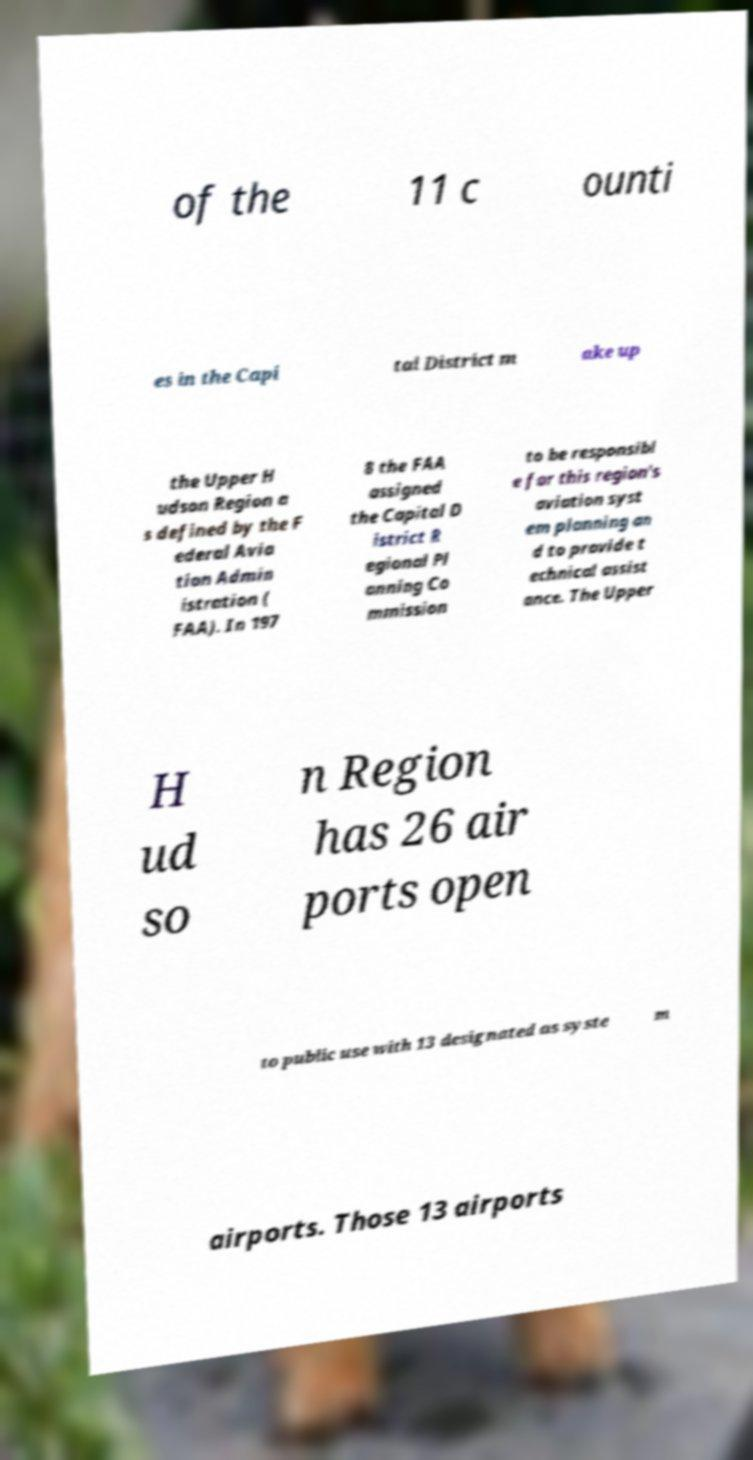Please identify and transcribe the text found in this image. of the 11 c ounti es in the Capi tal District m ake up the Upper H udson Region a s defined by the F ederal Avia tion Admin istration ( FAA). In 197 8 the FAA assigned the Capital D istrict R egional Pl anning Co mmission to be responsibl e for this region's aviation syst em planning an d to provide t echnical assist ance. The Upper H ud so n Region has 26 air ports open to public use with 13 designated as syste m airports. Those 13 airports 